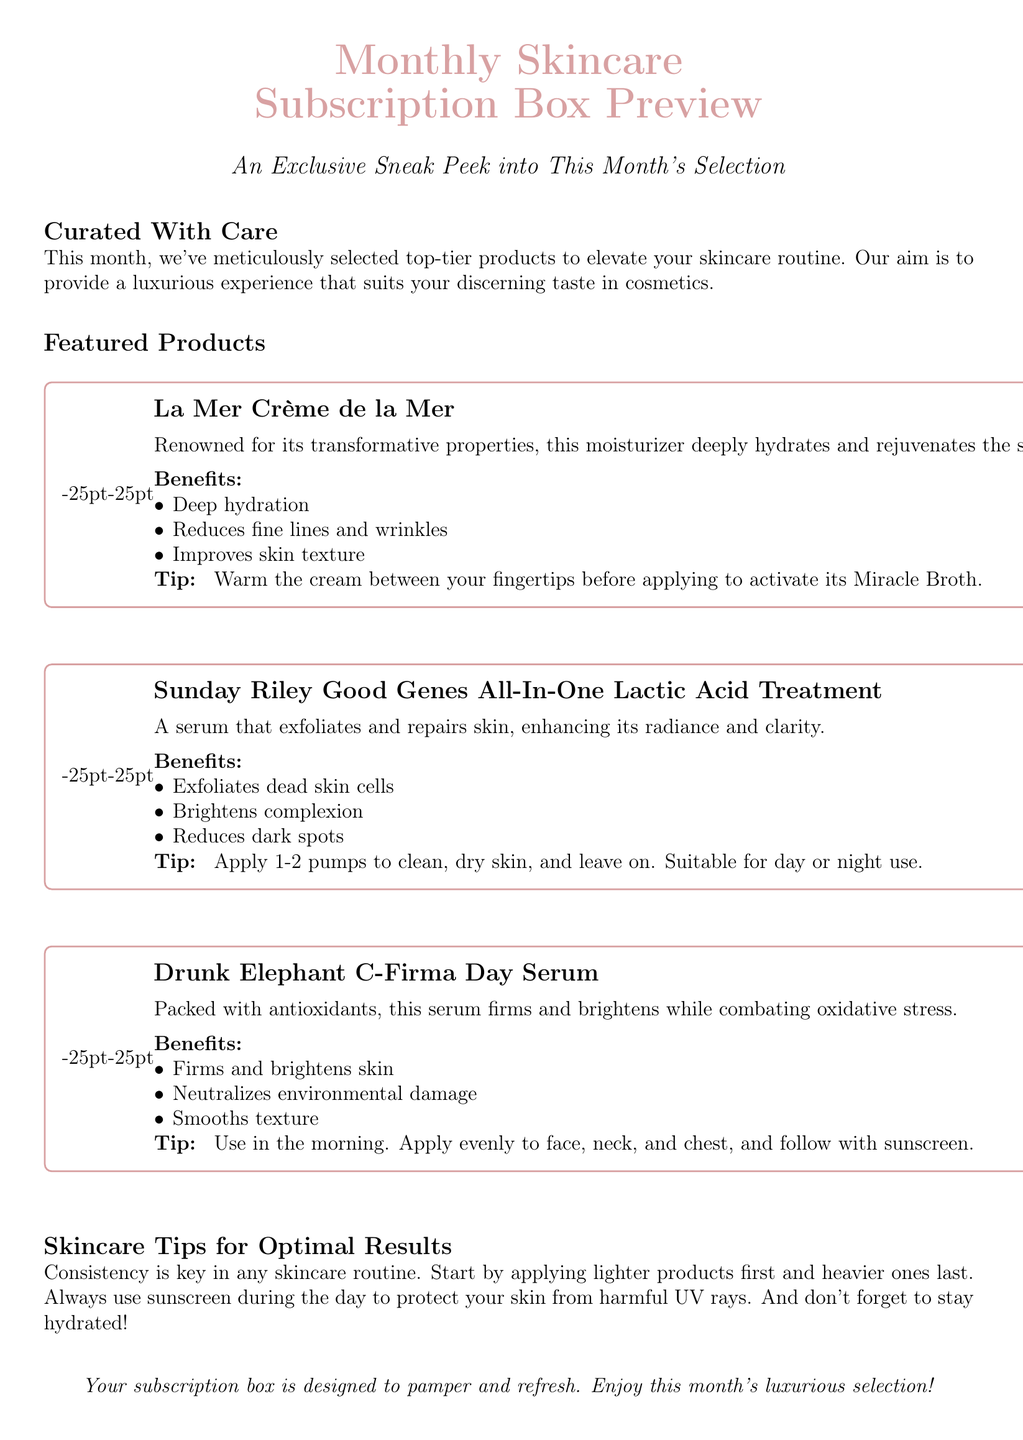what is the title of the document? The title is prominently displayed at the top and focuses on the content, which is a preview of a skincare subscription box.
Answer: Monthly Skincare Subscription Box Preview how many featured products are listed? The section labeled "Featured Products" includes three different products, indicating the quantity available in the subscription box.
Answer: 3 what is the key benefit of La Mer Crème de la Mer? The document states that La Mer Crème de la Mer offers transformative properties that help in hydration and rejuvenation, highlighting its primary function.
Answer: Deep hydration who is the manufacturer of Good Genes All-In-One? The product is attributed to a specific brand that is known for high-quality skincare treatments, which is mentioned in the document.
Answer: Sunday Riley what is a skincare tip provided in the document? A section dedicated to skincare tips offers insights for optimal results, clearly articulating the advice provided.
Answer: Consistency is key which product should be applied in the morning? The document specifies the recommended timing for product application, indicating one product is designated for morning use.
Answer: Drunk Elephant C-Firma Day Serum which ingredient is noted for its ability to exfoliate skin? The document describes a specific serum that contains an ingredient known for its exfoliating properties and effectiveness.
Answer: Lactic Acid what should be done before applying La Mer? Instructions for using the product are given, detailing a specific method for effective application.
Answer: Warm the cream between your fingertips 